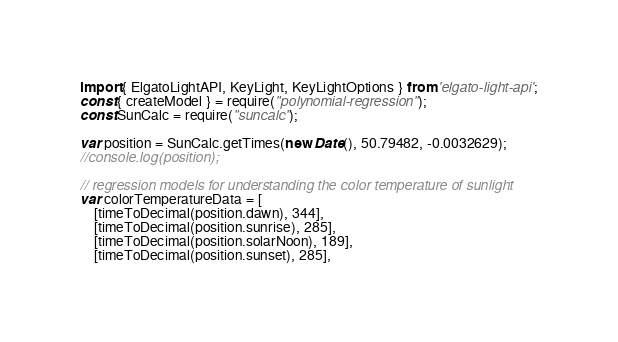<code> <loc_0><loc_0><loc_500><loc_500><_TypeScript_>import { ElgatoLightAPI, KeyLight, KeyLightOptions } from 'elgato-light-api';
const { createModel } = require("polynomial-regression");
const SunCalc = require("suncalc");

var position = SunCalc.getTimes(new Date(), 50.79482, -0.0032629);
//console.log(position);

// regression models for understanding the color temperature of sunlight
var colorTemperatureData = [
    [timeToDecimal(position.dawn), 344],
    [timeToDecimal(position.sunrise), 285],
    [timeToDecimal(position.solarNoon), 189],
    [timeToDecimal(position.sunset), 285],</code> 